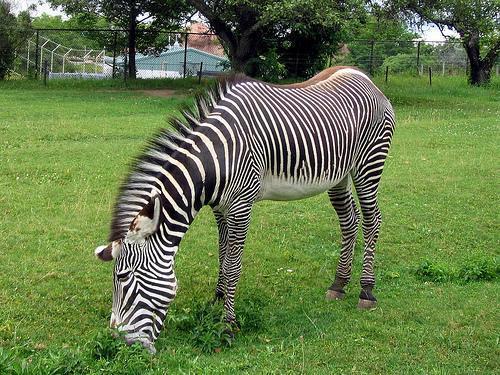How many zebras are in the photo?
Give a very brief answer. 1. 